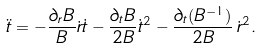<formula> <loc_0><loc_0><loc_500><loc_500>\ddot { t } = - \frac { \partial _ { r } B } { B } \dot { r } \dot { t } - \frac { \partial _ { t } B } { 2 B } \dot { t } ^ { 2 } - \frac { \partial _ { t } ( B ^ { - 1 } ) } { 2 B } \, \dot { r } ^ { 2 } .</formula> 